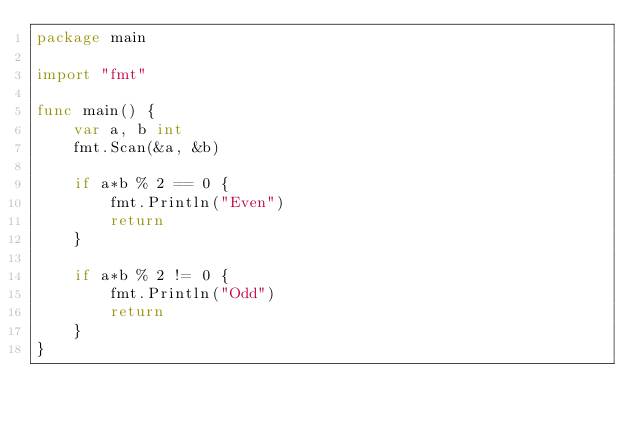Convert code to text. <code><loc_0><loc_0><loc_500><loc_500><_Go_>package main

import "fmt"

func main() {
    var a, b int
    fmt.Scan(&a, &b)

    if a*b % 2 == 0 {
        fmt.Println("Even")
        return
    }
    
    if a*b % 2 != 0 {
        fmt.Println("Odd")
        return
    }
}</code> 